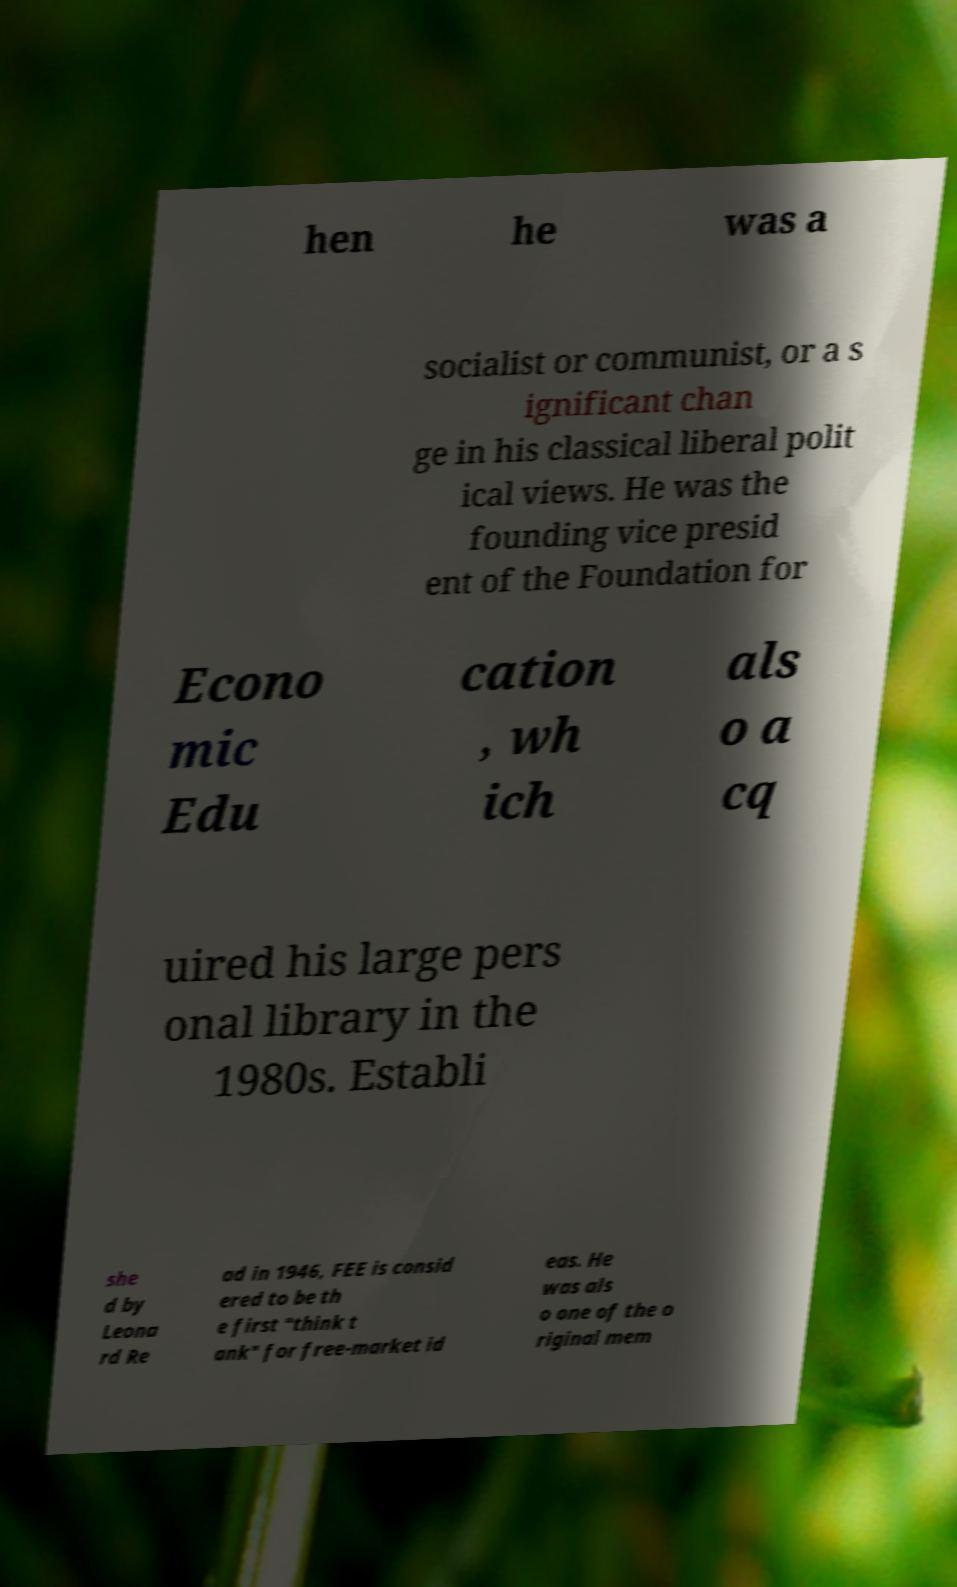I need the written content from this picture converted into text. Can you do that? hen he was a socialist or communist, or a s ignificant chan ge in his classical liberal polit ical views. He was the founding vice presid ent of the Foundation for Econo mic Edu cation , wh ich als o a cq uired his large pers onal library in the 1980s. Establi she d by Leona rd Re ad in 1946, FEE is consid ered to be th e first "think t ank" for free-market id eas. He was als o one of the o riginal mem 